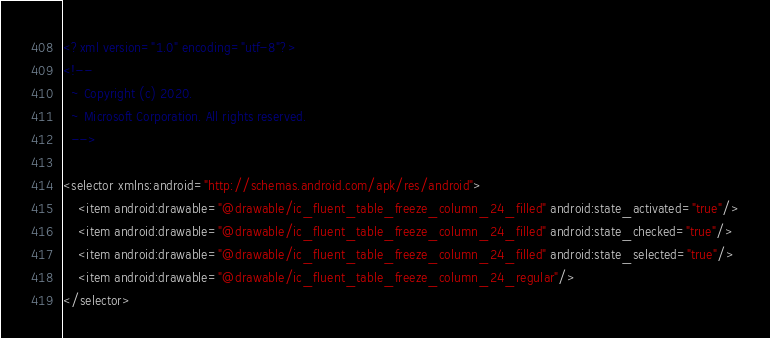Convert code to text. <code><loc_0><loc_0><loc_500><loc_500><_XML_><?xml version="1.0" encoding="utf-8"?>
<!--
  ~ Copyright (c) 2020.
  ~ Microsoft Corporation. All rights reserved.
  -->

<selector xmlns:android="http://schemas.android.com/apk/res/android">
    <item android:drawable="@drawable/ic_fluent_table_freeze_column_24_filled" android:state_activated="true"/>
    <item android:drawable="@drawable/ic_fluent_table_freeze_column_24_filled" android:state_checked="true"/>
    <item android:drawable="@drawable/ic_fluent_table_freeze_column_24_filled" android:state_selected="true"/>
    <item android:drawable="@drawable/ic_fluent_table_freeze_column_24_regular"/>
</selector>
</code> 